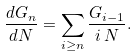<formula> <loc_0><loc_0><loc_500><loc_500>\frac { d G _ { n } } { d N } = \sum _ { i \geq n } \frac { G _ { i - 1 } } { i \, N } .</formula> 